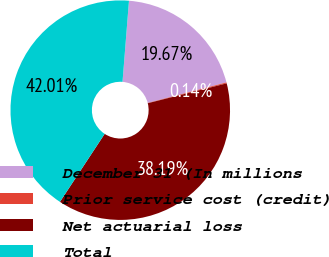Convert chart. <chart><loc_0><loc_0><loc_500><loc_500><pie_chart><fcel>December 31 (In millions<fcel>Prior service cost (credit)<fcel>Net actuarial loss<fcel>Total<nl><fcel>19.67%<fcel>0.14%<fcel>38.19%<fcel>42.01%<nl></chart> 